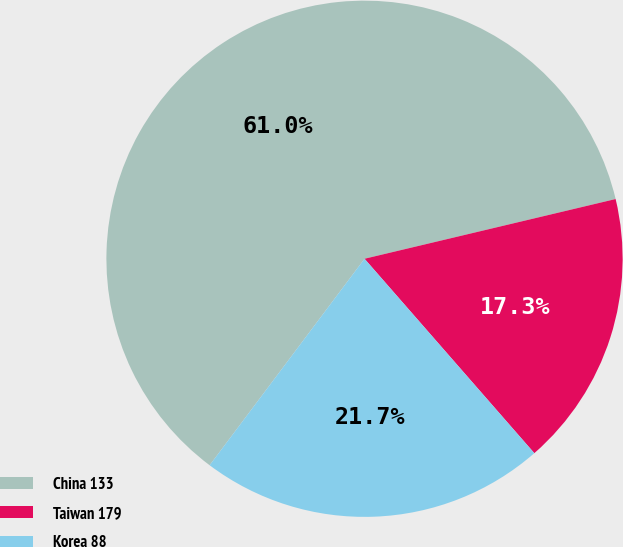Convert chart to OTSL. <chart><loc_0><loc_0><loc_500><loc_500><pie_chart><fcel>China 133<fcel>Taiwan 179<fcel>Korea 88<nl><fcel>61.04%<fcel>17.29%<fcel>21.67%<nl></chart> 